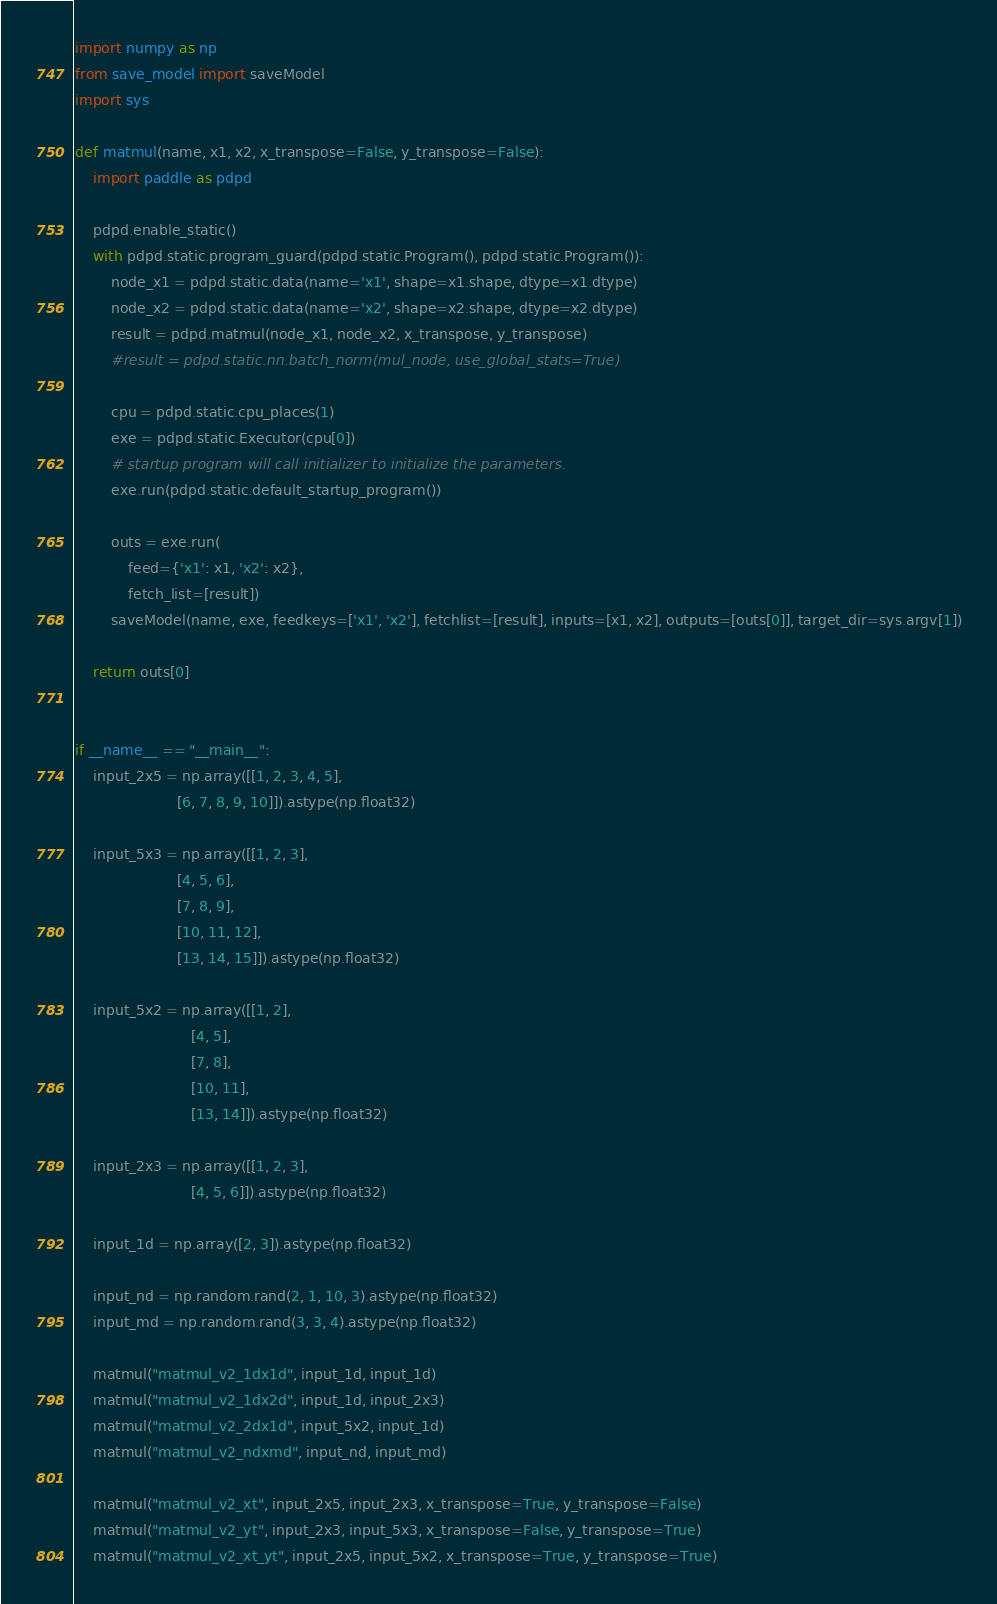<code> <loc_0><loc_0><loc_500><loc_500><_Python_>import numpy as np
from save_model import saveModel
import sys

def matmul(name, x1, x2, x_transpose=False, y_transpose=False):
    import paddle as pdpd

    pdpd.enable_static()
    with pdpd.static.program_guard(pdpd.static.Program(), pdpd.static.Program()):
        node_x1 = pdpd.static.data(name='x1', shape=x1.shape, dtype=x1.dtype)
        node_x2 = pdpd.static.data(name='x2', shape=x2.shape, dtype=x2.dtype)
        result = pdpd.matmul(node_x1, node_x2, x_transpose, y_transpose)
        #result = pdpd.static.nn.batch_norm(mul_node, use_global_stats=True)

        cpu = pdpd.static.cpu_places(1)
        exe = pdpd.static.Executor(cpu[0])
        # startup program will call initializer to initialize the parameters.
        exe.run(pdpd.static.default_startup_program())

        outs = exe.run(
            feed={'x1': x1, 'x2': x2},
            fetch_list=[result])
        saveModel(name, exe, feedkeys=['x1', 'x2'], fetchlist=[result], inputs=[x1, x2], outputs=[outs[0]], target_dir=sys.argv[1])

    return outs[0]


if __name__ == "__main__":
    input_2x5 = np.array([[1, 2, 3, 4, 5],
                       [6, 7, 8, 9, 10]]).astype(np.float32)

    input_5x3 = np.array([[1, 2, 3],
                       [4, 5, 6],
                       [7, 8, 9],
                       [10, 11, 12],
                       [13, 14, 15]]).astype(np.float32)

    input_5x2 = np.array([[1, 2],
                          [4, 5],
                          [7, 8],
                          [10, 11],
                          [13, 14]]).astype(np.float32)

    input_2x3 = np.array([[1, 2, 3],
                          [4, 5, 6]]).astype(np.float32)

    input_1d = np.array([2, 3]).astype(np.float32)

    input_nd = np.random.rand(2, 1, 10, 3).astype(np.float32)
    input_md = np.random.rand(3, 3, 4).astype(np.float32)

    matmul("matmul_v2_1dx1d", input_1d, input_1d)
    matmul("matmul_v2_1dx2d", input_1d, input_2x3)
    matmul("matmul_v2_2dx1d", input_5x2, input_1d)
    matmul("matmul_v2_ndxmd", input_nd, input_md)

    matmul("matmul_v2_xt", input_2x5, input_2x3, x_transpose=True, y_transpose=False)
    matmul("matmul_v2_yt", input_2x3, input_5x3, x_transpose=False, y_transpose=True)
    matmul("matmul_v2_xt_yt", input_2x5, input_5x2, x_transpose=True, y_transpose=True)
</code> 